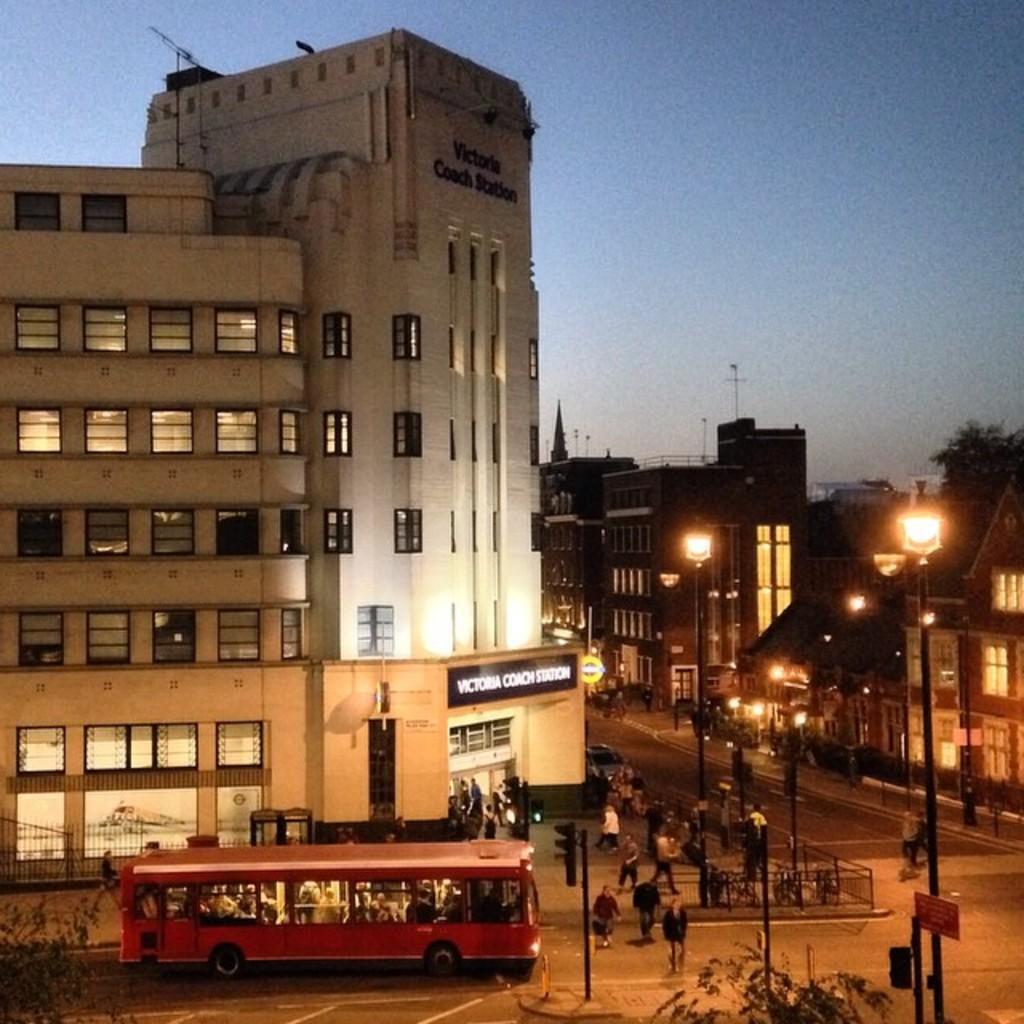Describe this image in one or two sentences. In this image I can see a vehicle in red color, I can also see few persons walking, a traffic signal, few light poles, buildings in white and brown color and the sky is in blue and white color. 